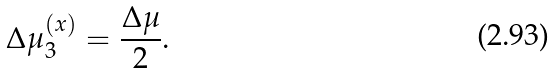<formula> <loc_0><loc_0><loc_500><loc_500>\Delta \mu _ { 3 } ^ { \left ( x \right ) } = \frac { \Delta \mu } { 2 } .</formula> 